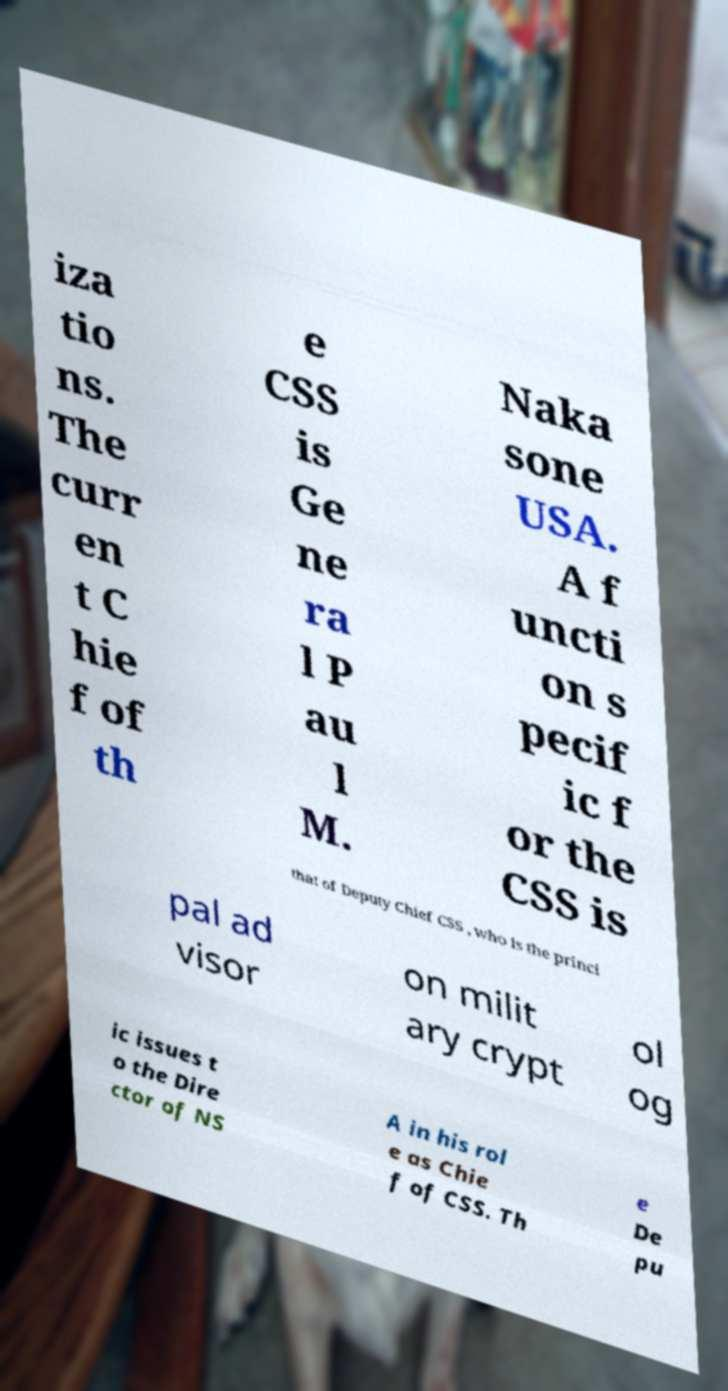What messages or text are displayed in this image? I need them in a readable, typed format. iza tio ns. The curr en t C hie f of th e CSS is Ge ne ra l P au l M. Naka sone USA. A f uncti on s pecif ic f or the CSS is that of Deputy Chief CSS , who is the princi pal ad visor on milit ary crypt ol og ic issues t o the Dire ctor of NS A in his rol e as Chie f of CSS. Th e De pu 